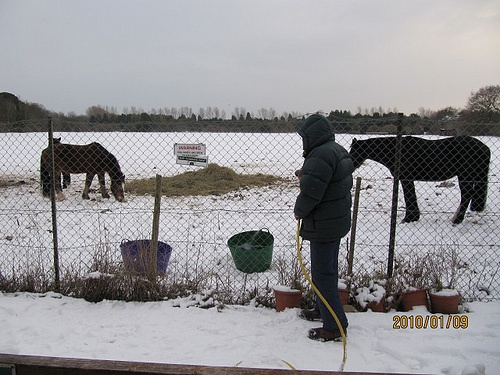Describe the objects in this image and their specific colors. I can see people in darkgray, black, lightgray, and gray tones, horse in darkgray, black, gray, and lightgray tones, and horse in darkgray, black, and gray tones in this image. 